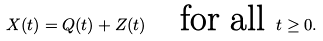Convert formula to latex. <formula><loc_0><loc_0><loc_500><loc_500>X ( t ) = Q ( t ) + Z ( t ) \quad \text {for all } t \geq 0 .</formula> 